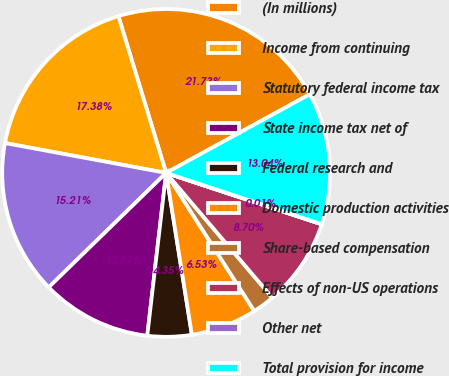Convert chart to OTSL. <chart><loc_0><loc_0><loc_500><loc_500><pie_chart><fcel>(In millions)<fcel>Income from continuing<fcel>Statutory federal income tax<fcel>State income tax net of<fcel>Federal research and<fcel>Domestic production activities<fcel>Share-based compensation<fcel>Effects of non-US operations<fcel>Other net<fcel>Total provision for income<nl><fcel>21.73%<fcel>17.38%<fcel>15.21%<fcel>10.87%<fcel>4.35%<fcel>6.53%<fcel>2.18%<fcel>8.7%<fcel>0.01%<fcel>13.04%<nl></chart> 